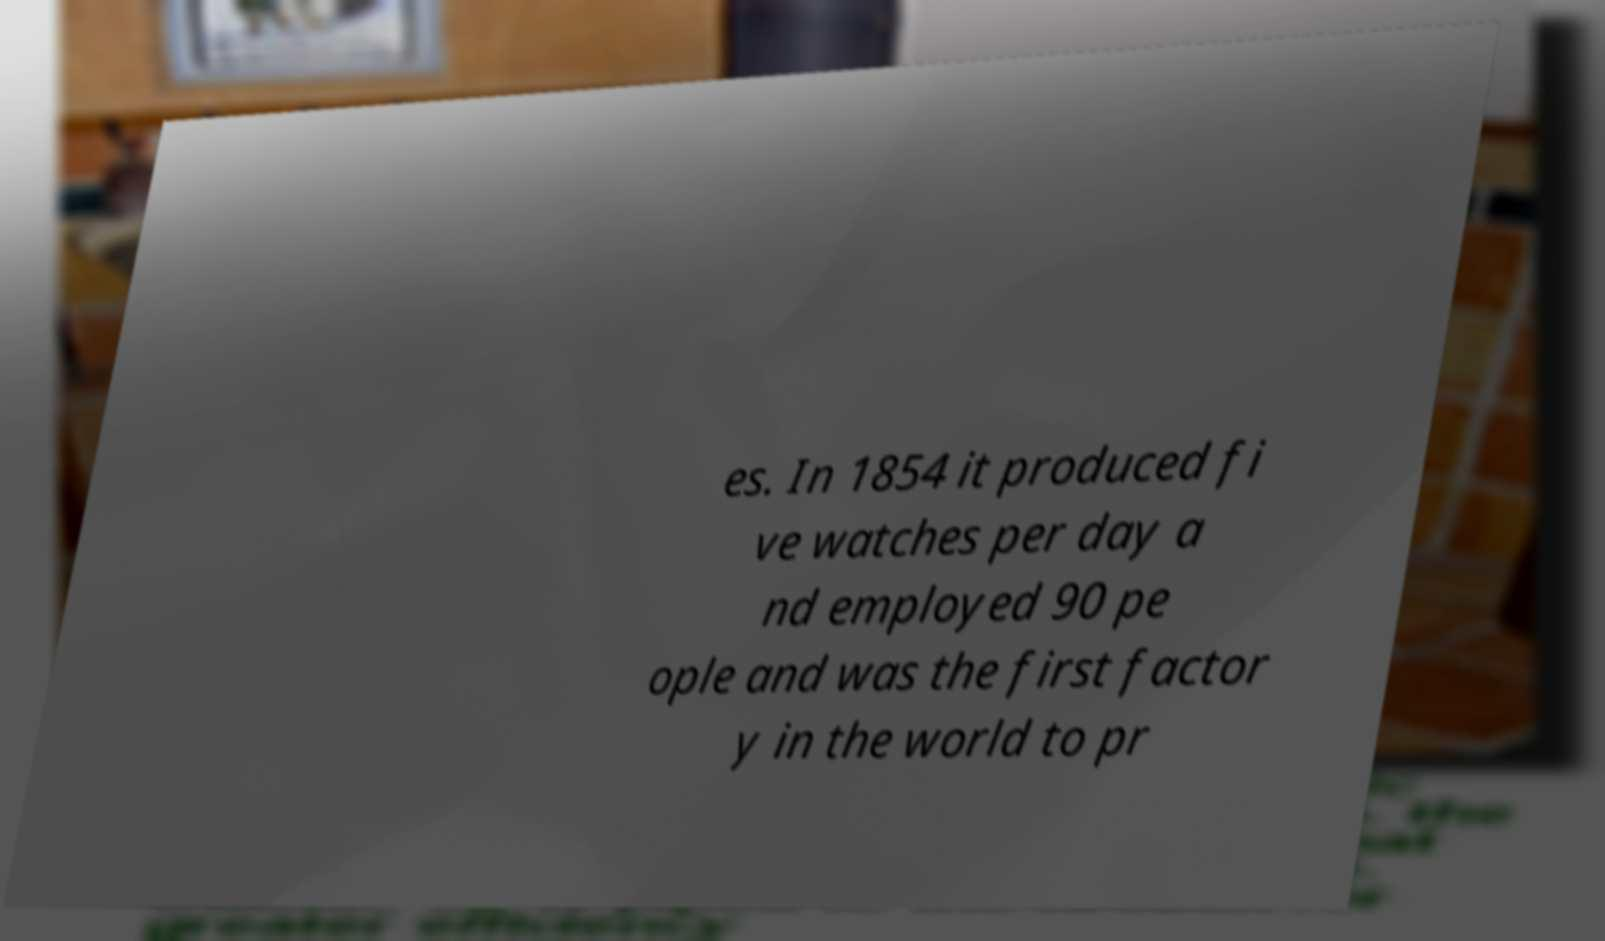I need the written content from this picture converted into text. Can you do that? es. In 1854 it produced fi ve watches per day a nd employed 90 pe ople and was the first factor y in the world to pr 